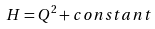Convert formula to latex. <formula><loc_0><loc_0><loc_500><loc_500>H = Q ^ { 2 } + c o n s t a n t</formula> 